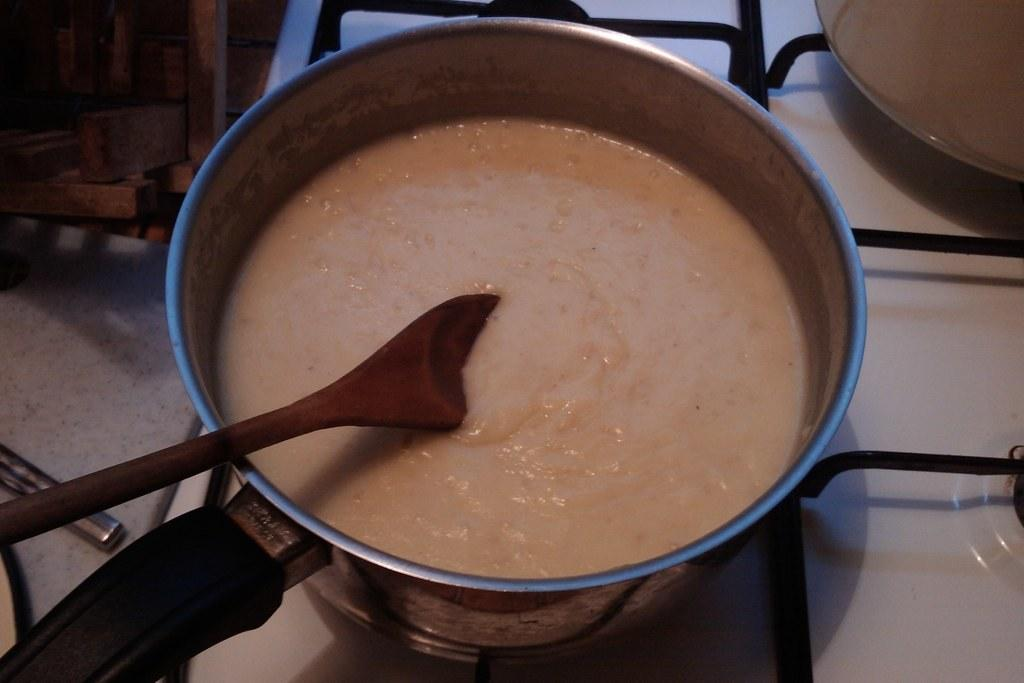What type of food item can be seen in the image? There is a food item in a utensil in the image. What utensil is present in the image? There is a spoon in the image. Can you describe the utensil in more detail? The utensil is present in the image, and it is a spoon. What type of square object can be seen in the image? There is no square object present in the image. Can you describe the market in the image? There is no market present in the image. 